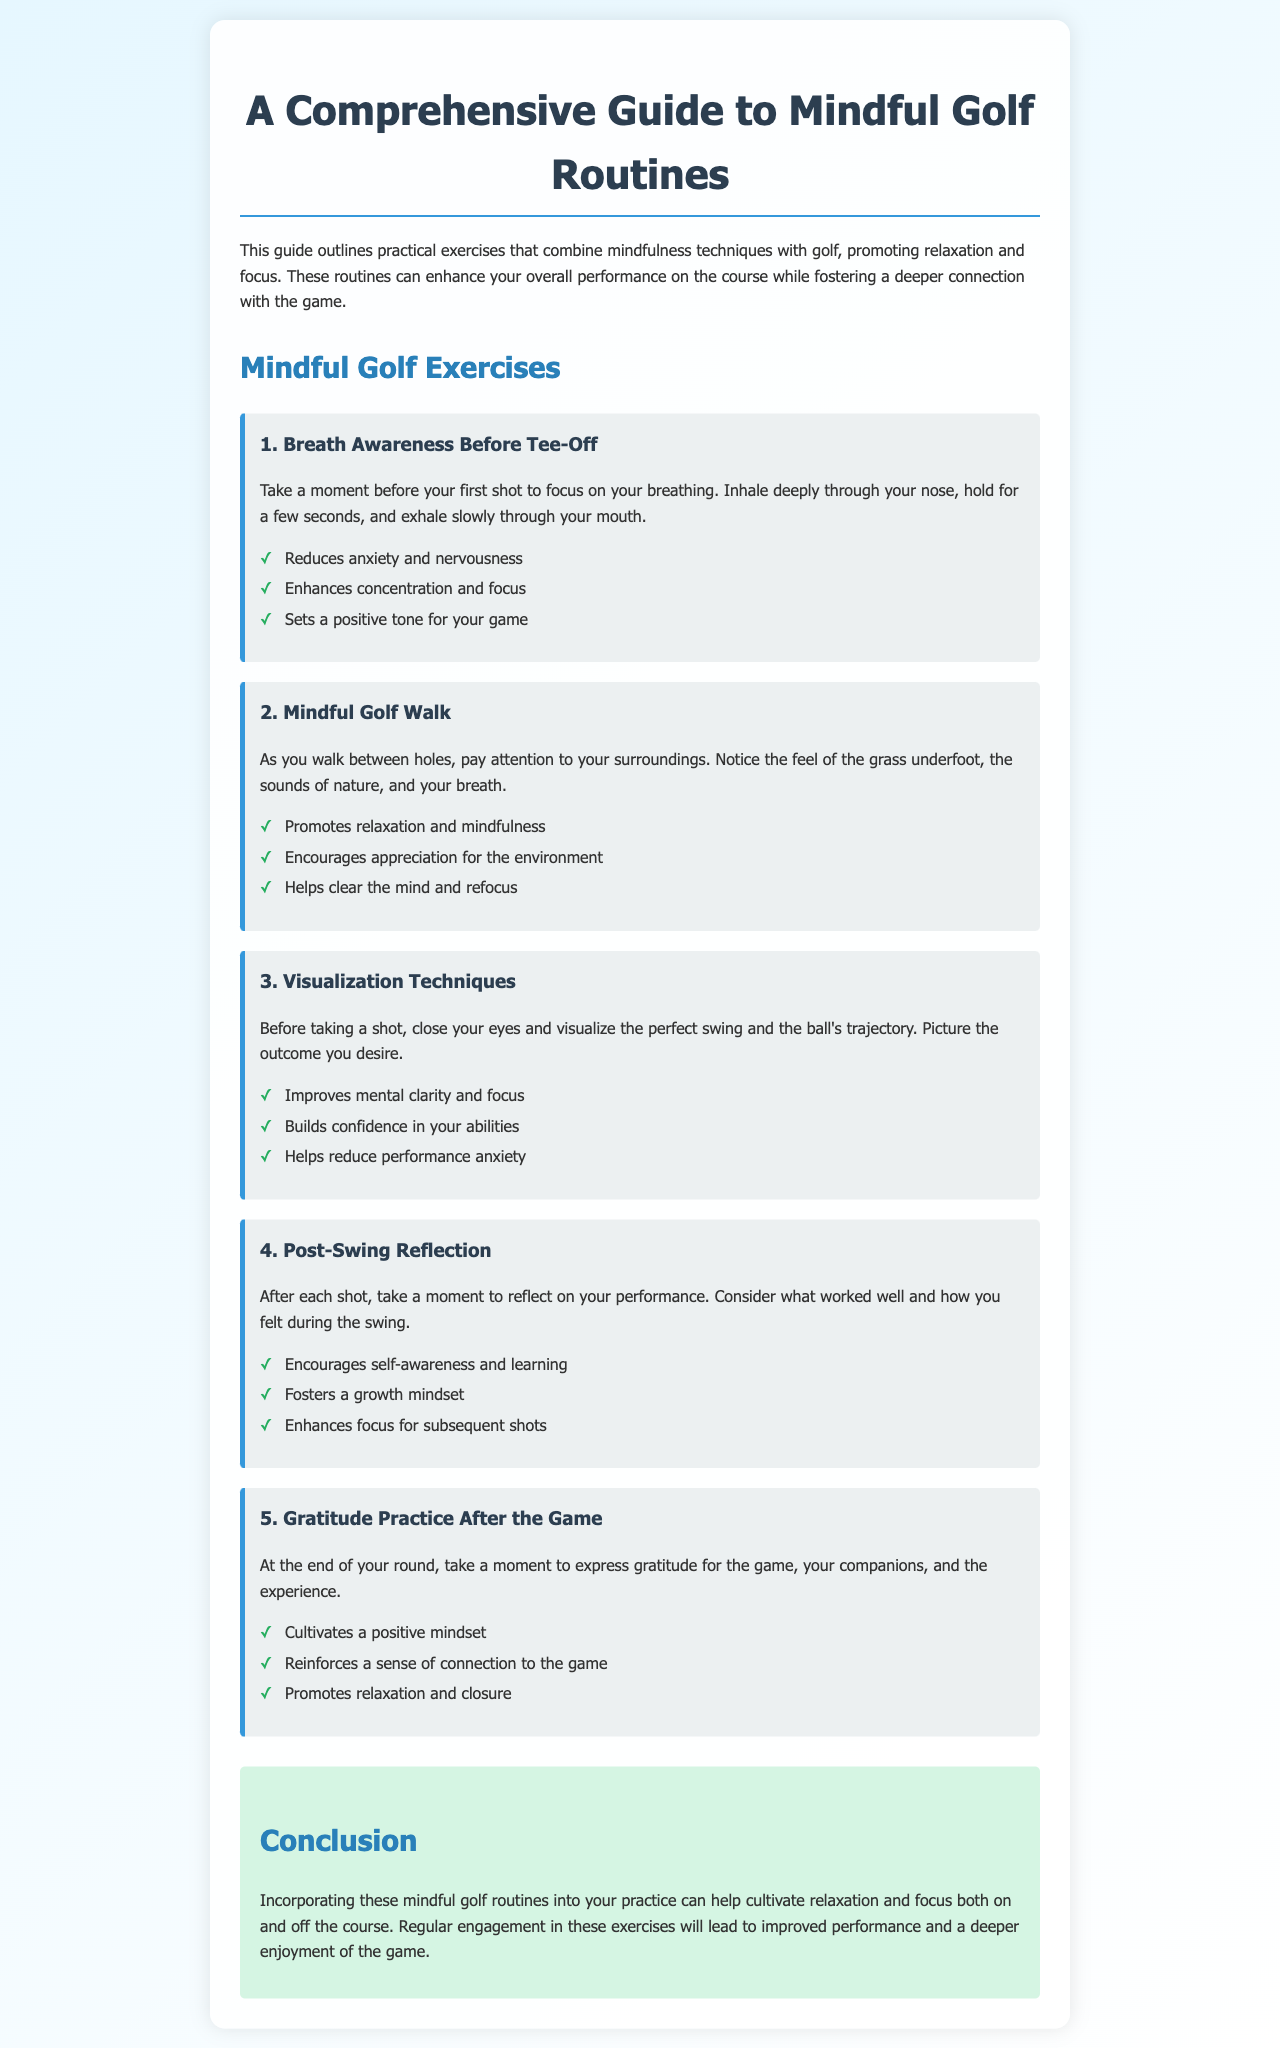what is the title of the guide? The title of the guide is presented in the h1 section of the document, which is "A Comprehensive Guide to Mindful Golf Routines."
Answer: A Comprehensive Guide to Mindful Golf Routines how many exercises are outlined in the guide? The guide lists a total of five exercises under the section "Mindful Golf Exercises."
Answer: 5 what is the first exercise mentioned? The first exercise is recorded as "Breath Awareness Before Tee-Off."
Answer: Breath Awareness Before Tee-Off what is one benefit of the "Mindful Golf Walk"? The benefits are listed under each exercise; one of the benefits is "Promotes relaxation and mindfulness."
Answer: Promotes relaxation and mindfulness what does the "Gratitude Practice After the Game" help to cultivate? The benefits for this exercise include cultivating a positive mindset, which is explicitly mentioned.
Answer: a positive mindset what is suggested to visualize before taking a shot? It is suggested to visualize "the perfect swing and the ball's trajectory."
Answer: the perfect swing and the ball's trajectory how does "Post-Swing Reflection" enhance focus? This exercise fosters a growth mindset which is likely to improve focus for subsequent shots.
Answer: Enhances focus for subsequent shots what color scheme is used in the document's design? The document features a gradient of light blue transitioning to white, predominantly with shades of blue and green for specific elements.
Answer: light blue and white what is the conclusion's main message? The conclusion emphasizes the importance of incorporating mindful golf routines for improvements in relaxation and focus.
Answer: improved performance and a deeper enjoyment of the game 